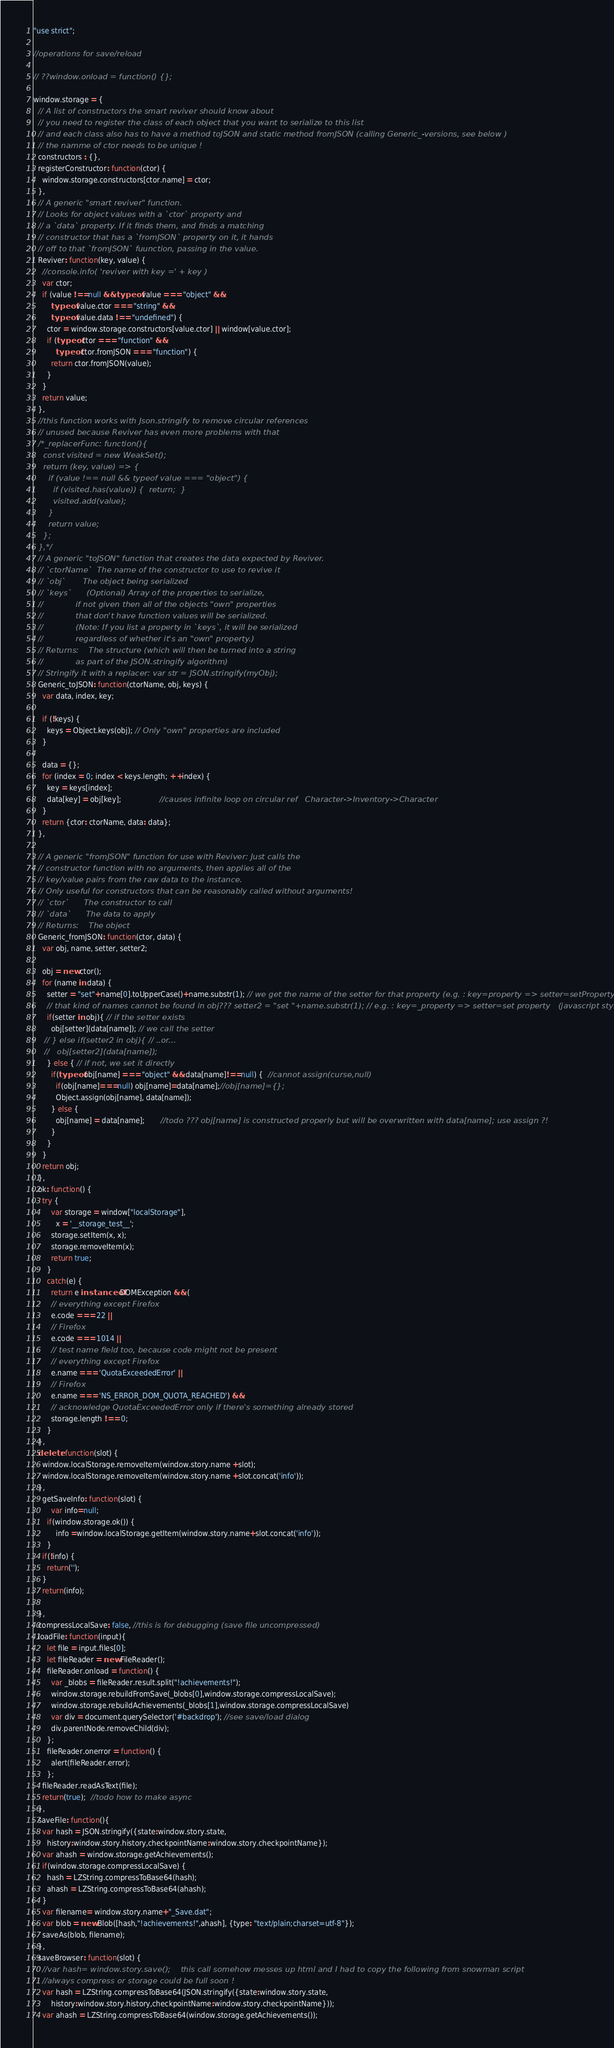Convert code to text. <code><loc_0><loc_0><loc_500><loc_500><_JavaScript_>"use strict";

//operations for save/reload

// ??window.onload = function() {};

window.storage = {  
  // A list of constructors the smart reviver should know about  
  // you need to register the class of each object that you want to serialize to this list
  // and each class also has to have a method toJSON and static method fromJSON (calling Generic_-versions, see below )
  // the namme of ctor needs to be unique !
  constructors : {}, 
  registerConstructor: function(ctor) {
    window.storage.constructors[ctor.name] = ctor;
  },
  // A generic "smart reviver" function.
  // Looks for object values with a `ctor` property and
  // a `data` property. If it finds them, and finds a matching
  // constructor that has a `fromJSON` property on it, it hands
  // off to that `fromJSON` fuunction, passing in the value.
  Reviver: function(key, value) {
    //console.info( 'reviver with key =' + key )
    var ctor;
    if (value !==null && typeof value === "object" &&
        typeof value.ctor === "string" &&
        typeof value.data !== "undefined") {
      ctor = window.storage.constructors[value.ctor] || window[value.ctor];
      if (typeof ctor === "function" &&
          typeof ctor.fromJSON === "function") {
        return ctor.fromJSON(value);
      }
    }
    return value;
  },
  //this function works with Json.stringify to remove circular references
  // unused because Reviver has even more problems with that
  /*_replacerFunc: function(){
    const visited = new WeakSet();
    return (key, value) => {
      if (value !== null && typeof value === "object") {
        if (visited.has(value)) {  return;  }
        visited.add(value);
      }
      return value;
    };
  },*/ 
  // A generic "toJSON" function that creates the data expected by Reviver.
  // `ctorName`  The name of the constructor to use to revive it
  // `obj`       The object being serialized
  // `keys`      (Optional) Array of the properties to serialize,
  //             if not given then all of the objects "own" properties
  //             that don't have function values will be serialized.
  //             (Note: If you list a property in `keys`, it will be serialized
  //             regardless of whether it's an "own" property.)
  // Returns:    The structure (which will then be turned into a string
  //             as part of the JSON.stringify algorithm)
  // Stringify it with a replacer: var str = JSON.stringify(myObj);
  Generic_toJSON: function(ctorName, obj, keys) {
    var data, index, key;
    
    if (!keys) {
      keys = Object.keys(obj); // Only "own" properties are included
    }
    
    data = {};
    for (index = 0; index < keys.length; ++index) {
      key = keys[index];
      data[key] = obj[key];                 //causes infinite loop on circular ref   Character->Inventory->Character
    }
    return {ctor: ctorName, data: data};
  },
  
  // A generic "fromJSON" function for use with Reviver: Just calls the
  // constructor function with no arguments, then applies all of the
  // key/value pairs from the raw data to the instance.
  // Only useful for constructors that can be reasonably called without arguments!
  // `ctor`      The constructor to call
  // `data`      The data to apply
  // Returns:    The object
  Generic_fromJSON: function(ctor, data) {
    var obj, name, setter, setter2;
    
    obj = new ctor();
    for (name in data) {
      setter = "set"+name[0].toUpperCase()+name.substr(1); // we get the name of the setter for that property (e.g. : key=property => setter=setProperty
      // that kind of names cannot be found in obj??? setter2 = "set "+name.substr(1); // e.g. : key=_property => setter=set property   (javascript style setter)
      if(setter in obj){ // if the setter exists 
        obj[setter](data[name]); // we call the setter
     // } else if(setter2 in obj){ // ..or...
     //   obj[setter2](data[name]); 
      } else { // if not, we set it directly
        if(typeof obj[name] === "object" && data[name]!==null) {  //cannot assign(curse,null)
          if(obj[name]===null) obj[name]=data[name];//obj[name]={};
          Object.assign(obj[name], data[name]);
        } else {
          obj[name] = data[name];       //todo ??? obj[name] is constructed properly but will be overwritten with data[name]; use assign ?!
        }
      }
    }
    return obj;
  },
  ok: function() {
    try {
        var storage = window["localStorage"],
          x = '__storage_test__';
        storage.setItem(x, x);
        storage.removeItem(x);
        return true;
      }
      catch(e) {
        return e instanceof DOMException && (
        // everything except Firefox
        e.code === 22 ||
        // Firefox
        e.code === 1014 ||
        // test name field too, because code might not be present
        // everything except Firefox
        e.name === 'QuotaExceededError' ||
        // Firefox
        e.name === 'NS_ERROR_DOM_QUOTA_REACHED') &&
        // acknowledge QuotaExceededError only if there's something already stored
        storage.length !== 0;
      }
  },
  delete: function(slot) {
    window.localStorage.removeItem(window.story.name +slot);
    window.localStorage.removeItem(window.story.name +slot.concat('info'));
  },
    getSaveInfo: function(slot) {
        var info=null;
      if(window.storage.ok()) {
          info =window.localStorage.getItem(window.story.name+slot.concat('info'));		
      }
    if(!info) {
      return('');
    }
    return(info);
      
  },
  compressLocalSave: false, //this is for debugging (save file uncompressed)
  loadFile: function(input){
      let file = input.files[0]; 
      let fileReader = new FileReader(); 
      fileReader.onload = function() {
        var _blobs = fileReader.result.split("!achievements!");
        window.storage.rebuildFromSave(_blobs[0],window.storage.compressLocalSave);
        window.storage.rebuildAchievements(_blobs[1],window.storage.compressLocalSave)
        var div = document.querySelector('#backdrop'); //see save/load dialog
        div.parentNode.removeChild(div);
      }; 
      fileReader.onerror = function() {
        alert(fileReader.error);
      }; 
    fileReader.readAsText(file);
    return(true);  //todo how to make async
  },
  saveFile: function(){
    var hash = JSON.stringify({state:window.story.state,
      history:window.story.history,checkpointName:window.story.checkpointName});
    var ahash = window.storage.getAchievements();
    if(window.storage.compressLocalSave) {
      hash = LZString.compressToBase64(hash);
      ahash = LZString.compressToBase64(ahash);
    }
    var filename= window.story.name+"_Save.dat";
    var blob = new Blob([hash,"!achievements!",ahash], {type: "text/plain;charset=utf-8"});
    saveAs(blob, filename);
  },
  saveBrowser: function(slot) {
    //var hash= window.story.save();    this call somehow messes up html and I had to copy the following from snowman script
    //always compress or storage could be full soon !
    var hash = LZString.compressToBase64(JSON.stringify({state:window.story.state,
        history:window.story.history,checkpointName:window.story.checkpointName}));
    var ahash = LZString.compressToBase64(window.storage.getAchievements());</code> 